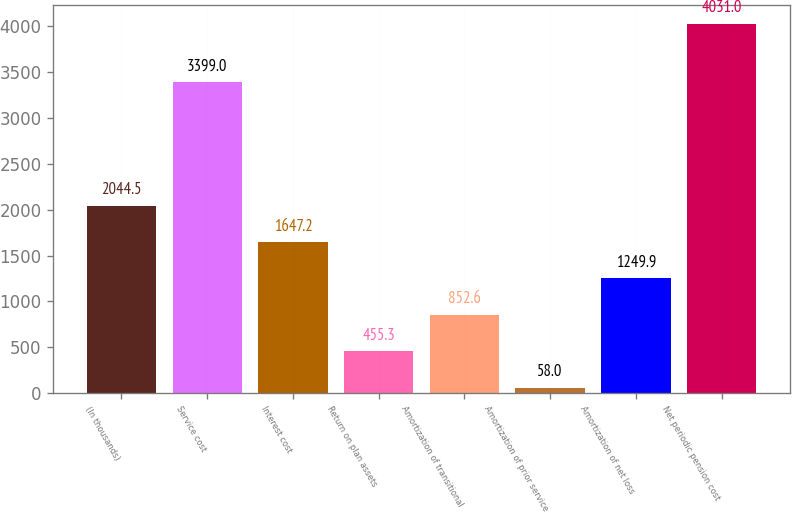Convert chart to OTSL. <chart><loc_0><loc_0><loc_500><loc_500><bar_chart><fcel>(In thousands)<fcel>Service cost<fcel>Interest cost<fcel>Return on plan assets<fcel>Amortization of transitional<fcel>Amortization of prior service<fcel>Amortization of net loss<fcel>Net periodic pension cost<nl><fcel>2044.5<fcel>3399<fcel>1647.2<fcel>455.3<fcel>852.6<fcel>58<fcel>1249.9<fcel>4031<nl></chart> 